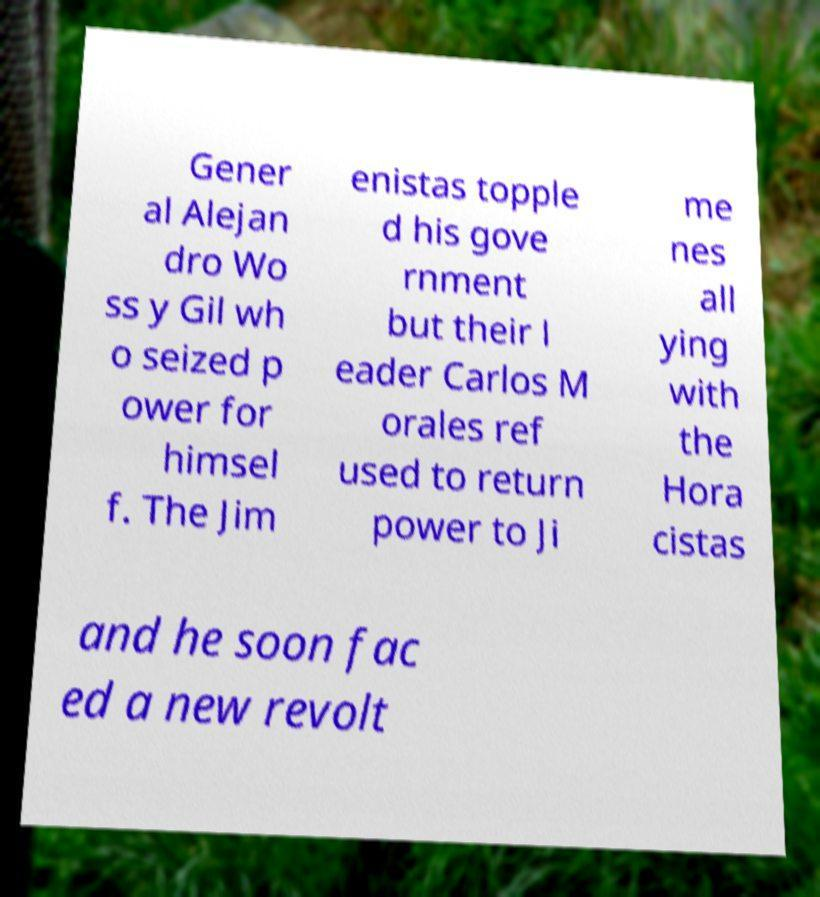Please read and relay the text visible in this image. What does it say? Gener al Alejan dro Wo ss y Gil wh o seized p ower for himsel f. The Jim enistas topple d his gove rnment but their l eader Carlos M orales ref used to return power to Ji me nes all ying with the Hora cistas and he soon fac ed a new revolt 